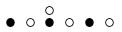Convert formula to latex. <formula><loc_0><loc_0><loc_500><loc_500>\begin{smallmatrix} & & \circ \\ \bullet & \circ & \bullet & \circ & \bullet & \circ & \\ \end{smallmatrix}</formula> 